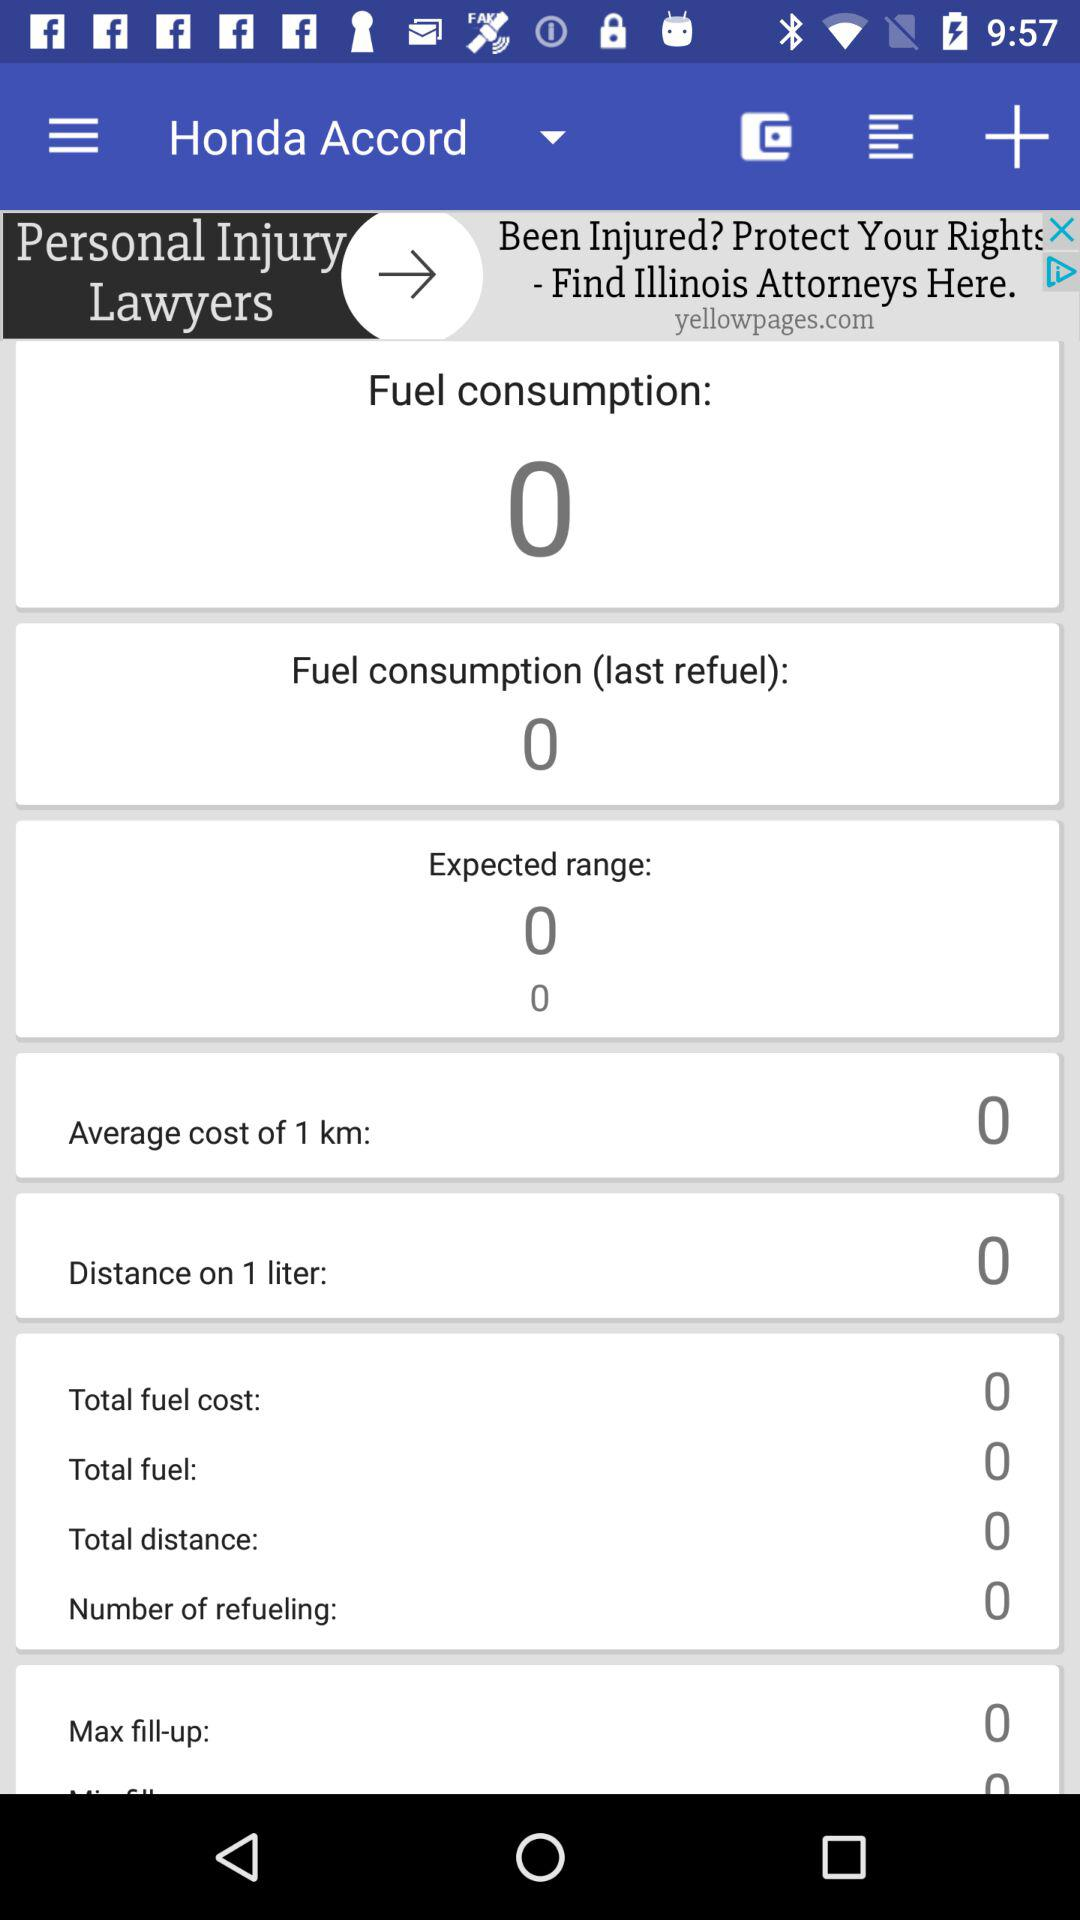What is the total fuel cost? The total fuel cost is 0. 